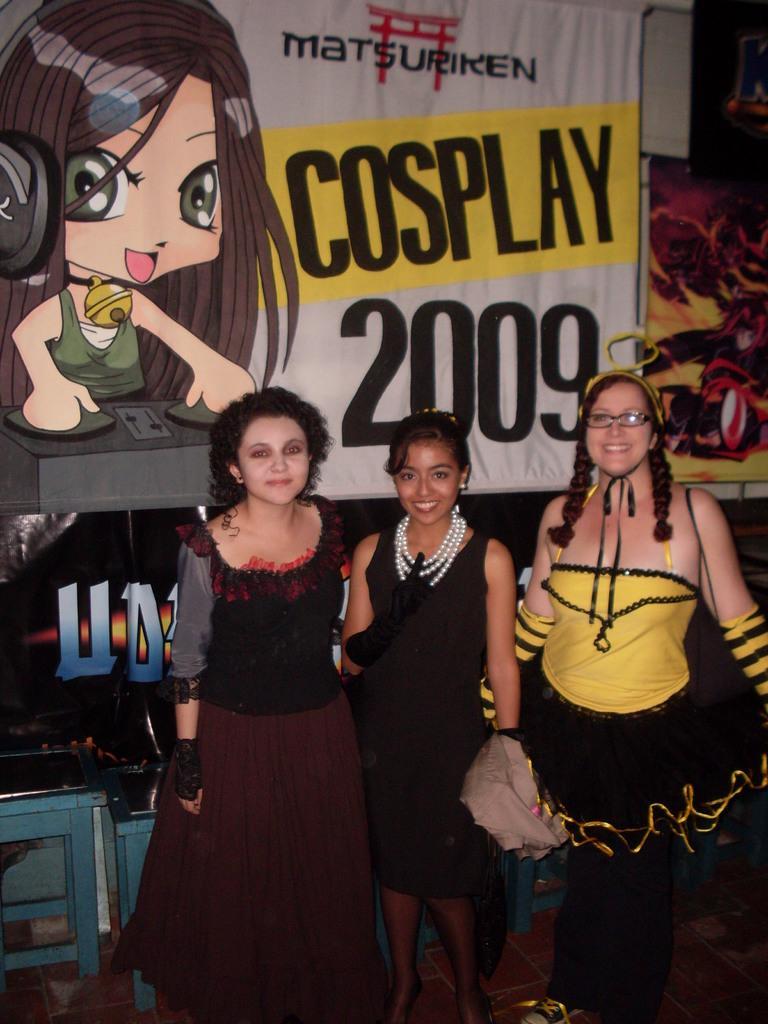Could you give a brief overview of what you see in this image? In the center of the image there are three persons standing. In the background of the image there is a banner. 